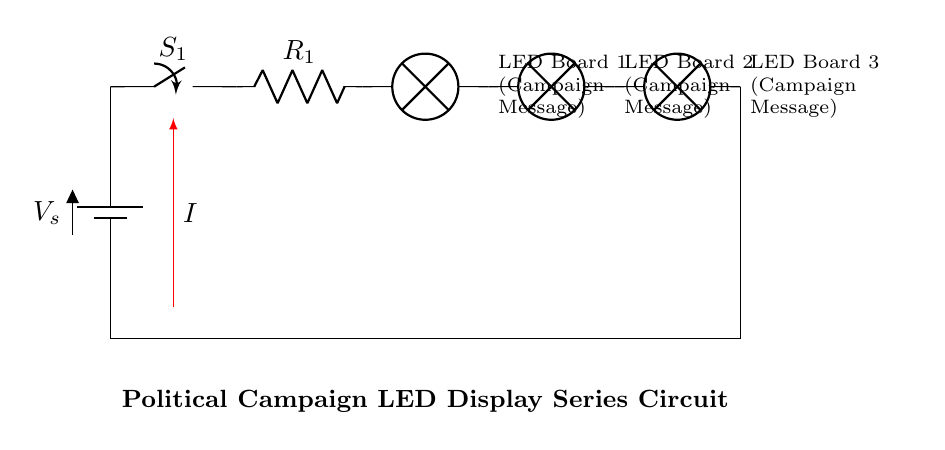What is the voltage source in this circuit? The voltage source in this circuit is represented by the battery labeled as V_s.
Answer: V_s How many LED boards are present in the circuit? There are three LED boards connected in series, each represented as a lamp symbol in the diagram.
Answer: 3 What type of circuit configuration is used here? The circuit is in a series configuration, where all components are connected end-to-end in a single path for current flow.
Answer: Series What is the role of the switch in this circuit? The switch, labeled S_1, controls the flow of current in the circuit, allowing the user to turn the circuit on or off.
Answer: Control current What happens to the total resistance if one of the resistors is removed? In a series circuit, removing a resistor would decrease the total resistance as it removes one of the resistive components affecting the overall current flow.
Answer: Decrease What is the current direction in this circuit? The current direction is indicated by the red arrow pointing from the positive side of the battery, moving through the circuit towards the negative terminal.
Answer: From battery to LED boards How would the brightness of the LED boards change if one more LED is added? Adding another LED board in series would increase the total resistance, causing the overall current to decrease, which would likely reduce the brightness of all LED boards.
Answer: Decrease brightness 